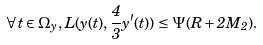<formula> <loc_0><loc_0><loc_500><loc_500>\forall \, t \in \Omega _ { y } , \, L ( y ( t ) , \frac { 4 } { 3 } y ^ { \prime } ( t ) ) \leq \Psi ( R + 2 M _ { 2 } ) .</formula> 